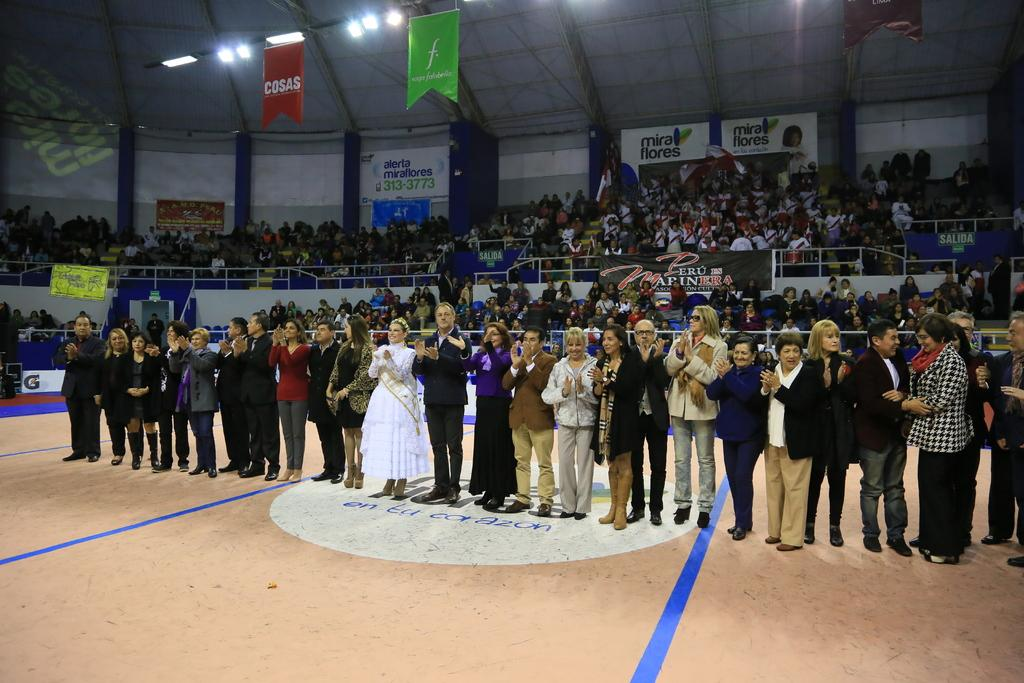What are the people in the image doing? The people in the image are standing on the ground. What can be seen in the background of the image? In the background of the image, there is a fence, a group of people, banners, posters, lights, a roof, and some unspecified objects. Can you describe the setting of the image? The image appears to be set in an outdoor area with a background that includes various structures and decorations. What type of smell can be detected from the horses in the image? There are no horses present in the image, so it is not possible to detect any smell from them. 